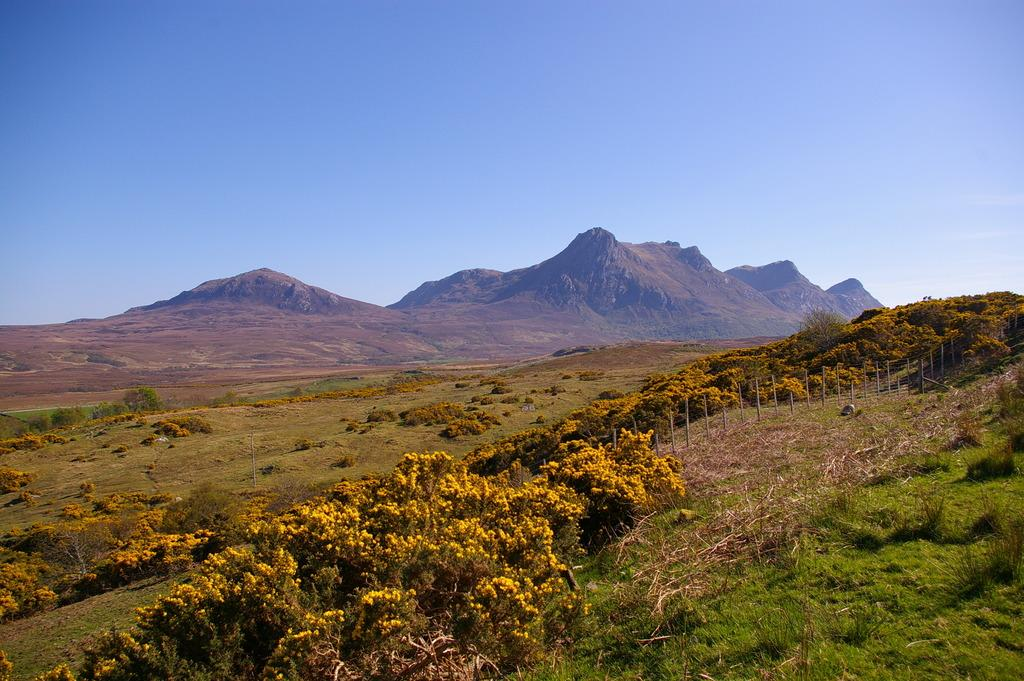What type of terrain is visible in the image? There is an open grass ground in the image. What can be found on the grass ground? There are trees and poles on the grass ground. What is visible in the background of the image? There are mountains, clouds, and the sky visible in the background of the image. What type of behavior can be observed in the argument between the trees and the mountains in the image? There is no behavior or argument between the trees and the mountains in the image; they are simply objects in the landscape. 